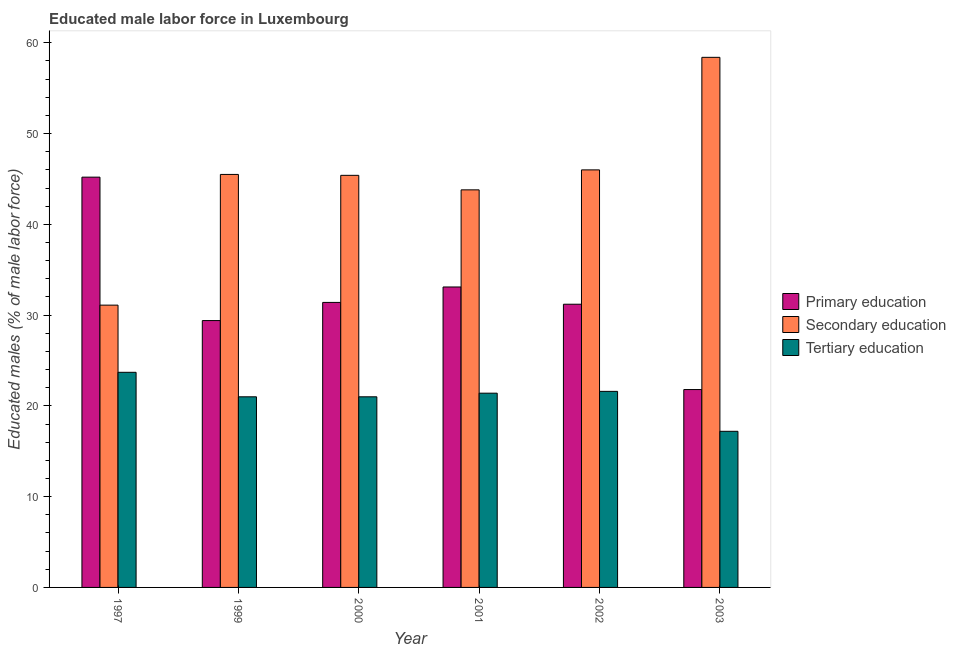How many groups of bars are there?
Offer a very short reply. 6. How many bars are there on the 4th tick from the right?
Your answer should be very brief. 3. What is the label of the 1st group of bars from the left?
Your answer should be compact. 1997. What is the percentage of male labor force who received tertiary education in 2002?
Give a very brief answer. 21.6. Across all years, what is the maximum percentage of male labor force who received tertiary education?
Make the answer very short. 23.7. Across all years, what is the minimum percentage of male labor force who received primary education?
Your answer should be compact. 21.8. In which year was the percentage of male labor force who received primary education minimum?
Make the answer very short. 2003. What is the total percentage of male labor force who received secondary education in the graph?
Offer a terse response. 270.2. What is the difference between the percentage of male labor force who received primary education in 2000 and that in 2001?
Keep it short and to the point. -1.7. What is the difference between the percentage of male labor force who received primary education in 1999 and the percentage of male labor force who received secondary education in 2001?
Your response must be concise. -3.7. What is the average percentage of male labor force who received secondary education per year?
Offer a terse response. 45.03. What is the ratio of the percentage of male labor force who received tertiary education in 1997 to that in 2002?
Ensure brevity in your answer.  1.1. Is the percentage of male labor force who received secondary education in 2002 less than that in 2003?
Your answer should be very brief. Yes. Is the difference between the percentage of male labor force who received tertiary education in 1997 and 2001 greater than the difference between the percentage of male labor force who received primary education in 1997 and 2001?
Give a very brief answer. No. What is the difference between the highest and the second highest percentage of male labor force who received secondary education?
Offer a very short reply. 12.4. What is the difference between the highest and the lowest percentage of male labor force who received tertiary education?
Your answer should be compact. 6.5. What does the 3rd bar from the left in 2001 represents?
Your answer should be compact. Tertiary education. Is it the case that in every year, the sum of the percentage of male labor force who received primary education and percentage of male labor force who received secondary education is greater than the percentage of male labor force who received tertiary education?
Keep it short and to the point. Yes. Are all the bars in the graph horizontal?
Provide a succinct answer. No. Does the graph contain any zero values?
Provide a short and direct response. No. Where does the legend appear in the graph?
Make the answer very short. Center right. How many legend labels are there?
Provide a succinct answer. 3. What is the title of the graph?
Your response must be concise. Educated male labor force in Luxembourg. Does "Transport" appear as one of the legend labels in the graph?
Make the answer very short. No. What is the label or title of the Y-axis?
Ensure brevity in your answer.  Educated males (% of male labor force). What is the Educated males (% of male labor force) of Primary education in 1997?
Your answer should be very brief. 45.2. What is the Educated males (% of male labor force) in Secondary education in 1997?
Offer a very short reply. 31.1. What is the Educated males (% of male labor force) of Tertiary education in 1997?
Provide a succinct answer. 23.7. What is the Educated males (% of male labor force) in Primary education in 1999?
Give a very brief answer. 29.4. What is the Educated males (% of male labor force) of Secondary education in 1999?
Keep it short and to the point. 45.5. What is the Educated males (% of male labor force) in Primary education in 2000?
Your answer should be very brief. 31.4. What is the Educated males (% of male labor force) of Secondary education in 2000?
Offer a very short reply. 45.4. What is the Educated males (% of male labor force) of Tertiary education in 2000?
Give a very brief answer. 21. What is the Educated males (% of male labor force) in Primary education in 2001?
Your answer should be compact. 33.1. What is the Educated males (% of male labor force) in Secondary education in 2001?
Your answer should be compact. 43.8. What is the Educated males (% of male labor force) in Tertiary education in 2001?
Offer a terse response. 21.4. What is the Educated males (% of male labor force) of Primary education in 2002?
Your answer should be very brief. 31.2. What is the Educated males (% of male labor force) of Secondary education in 2002?
Your response must be concise. 46. What is the Educated males (% of male labor force) in Tertiary education in 2002?
Make the answer very short. 21.6. What is the Educated males (% of male labor force) of Primary education in 2003?
Your answer should be compact. 21.8. What is the Educated males (% of male labor force) in Secondary education in 2003?
Give a very brief answer. 58.4. What is the Educated males (% of male labor force) in Tertiary education in 2003?
Your answer should be compact. 17.2. Across all years, what is the maximum Educated males (% of male labor force) of Primary education?
Keep it short and to the point. 45.2. Across all years, what is the maximum Educated males (% of male labor force) in Secondary education?
Ensure brevity in your answer.  58.4. Across all years, what is the maximum Educated males (% of male labor force) of Tertiary education?
Keep it short and to the point. 23.7. Across all years, what is the minimum Educated males (% of male labor force) of Primary education?
Give a very brief answer. 21.8. Across all years, what is the minimum Educated males (% of male labor force) of Secondary education?
Provide a succinct answer. 31.1. Across all years, what is the minimum Educated males (% of male labor force) in Tertiary education?
Ensure brevity in your answer.  17.2. What is the total Educated males (% of male labor force) of Primary education in the graph?
Your answer should be compact. 192.1. What is the total Educated males (% of male labor force) in Secondary education in the graph?
Provide a succinct answer. 270.2. What is the total Educated males (% of male labor force) in Tertiary education in the graph?
Offer a terse response. 125.9. What is the difference between the Educated males (% of male labor force) of Secondary education in 1997 and that in 1999?
Provide a short and direct response. -14.4. What is the difference between the Educated males (% of male labor force) in Tertiary education in 1997 and that in 1999?
Provide a succinct answer. 2.7. What is the difference between the Educated males (% of male labor force) of Secondary education in 1997 and that in 2000?
Your answer should be compact. -14.3. What is the difference between the Educated males (% of male labor force) of Tertiary education in 1997 and that in 2000?
Provide a short and direct response. 2.7. What is the difference between the Educated males (% of male labor force) in Primary education in 1997 and that in 2001?
Provide a succinct answer. 12.1. What is the difference between the Educated males (% of male labor force) of Tertiary education in 1997 and that in 2001?
Your answer should be compact. 2.3. What is the difference between the Educated males (% of male labor force) of Secondary education in 1997 and that in 2002?
Provide a succinct answer. -14.9. What is the difference between the Educated males (% of male labor force) of Primary education in 1997 and that in 2003?
Your answer should be compact. 23.4. What is the difference between the Educated males (% of male labor force) in Secondary education in 1997 and that in 2003?
Make the answer very short. -27.3. What is the difference between the Educated males (% of male labor force) of Primary education in 1999 and that in 2000?
Give a very brief answer. -2. What is the difference between the Educated males (% of male labor force) of Tertiary education in 1999 and that in 2000?
Your response must be concise. 0. What is the difference between the Educated males (% of male labor force) of Primary education in 1999 and that in 2001?
Your response must be concise. -3.7. What is the difference between the Educated males (% of male labor force) of Tertiary education in 1999 and that in 2001?
Offer a terse response. -0.4. What is the difference between the Educated males (% of male labor force) in Secondary education in 1999 and that in 2002?
Your answer should be very brief. -0.5. What is the difference between the Educated males (% of male labor force) of Primary education in 1999 and that in 2003?
Your answer should be very brief. 7.6. What is the difference between the Educated males (% of male labor force) of Secondary education in 2000 and that in 2001?
Your response must be concise. 1.6. What is the difference between the Educated males (% of male labor force) in Secondary education in 2000 and that in 2002?
Provide a succinct answer. -0.6. What is the difference between the Educated males (% of male labor force) of Secondary education in 2000 and that in 2003?
Provide a succinct answer. -13. What is the difference between the Educated males (% of male labor force) in Tertiary education in 2001 and that in 2002?
Give a very brief answer. -0.2. What is the difference between the Educated males (% of male labor force) of Primary education in 2001 and that in 2003?
Offer a very short reply. 11.3. What is the difference between the Educated males (% of male labor force) of Secondary education in 2001 and that in 2003?
Give a very brief answer. -14.6. What is the difference between the Educated males (% of male labor force) in Tertiary education in 2002 and that in 2003?
Keep it short and to the point. 4.4. What is the difference between the Educated males (% of male labor force) in Primary education in 1997 and the Educated males (% of male labor force) in Tertiary education in 1999?
Keep it short and to the point. 24.2. What is the difference between the Educated males (% of male labor force) in Secondary education in 1997 and the Educated males (% of male labor force) in Tertiary education in 1999?
Keep it short and to the point. 10.1. What is the difference between the Educated males (% of male labor force) of Primary education in 1997 and the Educated males (% of male labor force) of Secondary education in 2000?
Make the answer very short. -0.2. What is the difference between the Educated males (% of male labor force) in Primary education in 1997 and the Educated males (% of male labor force) in Tertiary education in 2000?
Ensure brevity in your answer.  24.2. What is the difference between the Educated males (% of male labor force) in Primary education in 1997 and the Educated males (% of male labor force) in Secondary education in 2001?
Offer a very short reply. 1.4. What is the difference between the Educated males (% of male labor force) in Primary education in 1997 and the Educated males (% of male labor force) in Tertiary education in 2001?
Your answer should be very brief. 23.8. What is the difference between the Educated males (% of male labor force) of Secondary education in 1997 and the Educated males (% of male labor force) of Tertiary education in 2001?
Keep it short and to the point. 9.7. What is the difference between the Educated males (% of male labor force) of Primary education in 1997 and the Educated males (% of male labor force) of Tertiary education in 2002?
Provide a succinct answer. 23.6. What is the difference between the Educated males (% of male labor force) of Primary education in 1997 and the Educated males (% of male labor force) of Secondary education in 2003?
Make the answer very short. -13.2. What is the difference between the Educated males (% of male labor force) in Primary education in 1997 and the Educated males (% of male labor force) in Tertiary education in 2003?
Make the answer very short. 28. What is the difference between the Educated males (% of male labor force) in Secondary education in 1997 and the Educated males (% of male labor force) in Tertiary education in 2003?
Offer a terse response. 13.9. What is the difference between the Educated males (% of male labor force) in Primary education in 1999 and the Educated males (% of male labor force) in Secondary education in 2000?
Offer a very short reply. -16. What is the difference between the Educated males (% of male labor force) of Secondary education in 1999 and the Educated males (% of male labor force) of Tertiary education in 2000?
Make the answer very short. 24.5. What is the difference between the Educated males (% of male labor force) of Primary education in 1999 and the Educated males (% of male labor force) of Secondary education in 2001?
Offer a very short reply. -14.4. What is the difference between the Educated males (% of male labor force) of Primary education in 1999 and the Educated males (% of male labor force) of Tertiary education in 2001?
Provide a succinct answer. 8. What is the difference between the Educated males (% of male labor force) of Secondary education in 1999 and the Educated males (% of male labor force) of Tertiary education in 2001?
Offer a very short reply. 24.1. What is the difference between the Educated males (% of male labor force) in Primary education in 1999 and the Educated males (% of male labor force) in Secondary education in 2002?
Give a very brief answer. -16.6. What is the difference between the Educated males (% of male labor force) in Primary education in 1999 and the Educated males (% of male labor force) in Tertiary education in 2002?
Keep it short and to the point. 7.8. What is the difference between the Educated males (% of male labor force) of Secondary education in 1999 and the Educated males (% of male labor force) of Tertiary education in 2002?
Your answer should be compact. 23.9. What is the difference between the Educated males (% of male labor force) of Primary education in 1999 and the Educated males (% of male labor force) of Tertiary education in 2003?
Your answer should be compact. 12.2. What is the difference between the Educated males (% of male labor force) of Secondary education in 1999 and the Educated males (% of male labor force) of Tertiary education in 2003?
Offer a terse response. 28.3. What is the difference between the Educated males (% of male labor force) of Primary education in 2000 and the Educated males (% of male labor force) of Secondary education in 2001?
Give a very brief answer. -12.4. What is the difference between the Educated males (% of male labor force) of Primary education in 2000 and the Educated males (% of male labor force) of Tertiary education in 2001?
Your answer should be compact. 10. What is the difference between the Educated males (% of male labor force) of Primary education in 2000 and the Educated males (% of male labor force) of Secondary education in 2002?
Offer a very short reply. -14.6. What is the difference between the Educated males (% of male labor force) of Secondary education in 2000 and the Educated males (% of male labor force) of Tertiary education in 2002?
Offer a terse response. 23.8. What is the difference between the Educated males (% of male labor force) of Primary education in 2000 and the Educated males (% of male labor force) of Secondary education in 2003?
Your response must be concise. -27. What is the difference between the Educated males (% of male labor force) of Secondary education in 2000 and the Educated males (% of male labor force) of Tertiary education in 2003?
Provide a short and direct response. 28.2. What is the difference between the Educated males (% of male labor force) in Primary education in 2001 and the Educated males (% of male labor force) in Secondary education in 2003?
Make the answer very short. -25.3. What is the difference between the Educated males (% of male labor force) of Secondary education in 2001 and the Educated males (% of male labor force) of Tertiary education in 2003?
Your answer should be compact. 26.6. What is the difference between the Educated males (% of male labor force) of Primary education in 2002 and the Educated males (% of male labor force) of Secondary education in 2003?
Your answer should be very brief. -27.2. What is the difference between the Educated males (% of male labor force) of Primary education in 2002 and the Educated males (% of male labor force) of Tertiary education in 2003?
Provide a succinct answer. 14. What is the difference between the Educated males (% of male labor force) of Secondary education in 2002 and the Educated males (% of male labor force) of Tertiary education in 2003?
Offer a terse response. 28.8. What is the average Educated males (% of male labor force) of Primary education per year?
Offer a very short reply. 32.02. What is the average Educated males (% of male labor force) of Secondary education per year?
Offer a very short reply. 45.03. What is the average Educated males (% of male labor force) in Tertiary education per year?
Make the answer very short. 20.98. In the year 1997, what is the difference between the Educated males (% of male labor force) in Secondary education and Educated males (% of male labor force) in Tertiary education?
Provide a short and direct response. 7.4. In the year 1999, what is the difference between the Educated males (% of male labor force) of Primary education and Educated males (% of male labor force) of Secondary education?
Keep it short and to the point. -16.1. In the year 1999, what is the difference between the Educated males (% of male labor force) in Primary education and Educated males (% of male labor force) in Tertiary education?
Give a very brief answer. 8.4. In the year 2000, what is the difference between the Educated males (% of male labor force) of Primary education and Educated males (% of male labor force) of Tertiary education?
Provide a succinct answer. 10.4. In the year 2000, what is the difference between the Educated males (% of male labor force) in Secondary education and Educated males (% of male labor force) in Tertiary education?
Provide a succinct answer. 24.4. In the year 2001, what is the difference between the Educated males (% of male labor force) in Primary education and Educated males (% of male labor force) in Tertiary education?
Your answer should be very brief. 11.7. In the year 2001, what is the difference between the Educated males (% of male labor force) of Secondary education and Educated males (% of male labor force) of Tertiary education?
Your response must be concise. 22.4. In the year 2002, what is the difference between the Educated males (% of male labor force) of Primary education and Educated males (% of male labor force) of Secondary education?
Your answer should be very brief. -14.8. In the year 2002, what is the difference between the Educated males (% of male labor force) in Secondary education and Educated males (% of male labor force) in Tertiary education?
Your answer should be very brief. 24.4. In the year 2003, what is the difference between the Educated males (% of male labor force) in Primary education and Educated males (% of male labor force) in Secondary education?
Provide a short and direct response. -36.6. In the year 2003, what is the difference between the Educated males (% of male labor force) of Primary education and Educated males (% of male labor force) of Tertiary education?
Provide a succinct answer. 4.6. In the year 2003, what is the difference between the Educated males (% of male labor force) in Secondary education and Educated males (% of male labor force) in Tertiary education?
Provide a short and direct response. 41.2. What is the ratio of the Educated males (% of male labor force) of Primary education in 1997 to that in 1999?
Keep it short and to the point. 1.54. What is the ratio of the Educated males (% of male labor force) in Secondary education in 1997 to that in 1999?
Ensure brevity in your answer.  0.68. What is the ratio of the Educated males (% of male labor force) of Tertiary education in 1997 to that in 1999?
Provide a short and direct response. 1.13. What is the ratio of the Educated males (% of male labor force) of Primary education in 1997 to that in 2000?
Provide a succinct answer. 1.44. What is the ratio of the Educated males (% of male labor force) in Secondary education in 1997 to that in 2000?
Your response must be concise. 0.69. What is the ratio of the Educated males (% of male labor force) in Tertiary education in 1997 to that in 2000?
Offer a very short reply. 1.13. What is the ratio of the Educated males (% of male labor force) in Primary education in 1997 to that in 2001?
Keep it short and to the point. 1.37. What is the ratio of the Educated males (% of male labor force) in Secondary education in 1997 to that in 2001?
Your answer should be compact. 0.71. What is the ratio of the Educated males (% of male labor force) in Tertiary education in 1997 to that in 2001?
Your answer should be very brief. 1.11. What is the ratio of the Educated males (% of male labor force) in Primary education in 1997 to that in 2002?
Offer a terse response. 1.45. What is the ratio of the Educated males (% of male labor force) in Secondary education in 1997 to that in 2002?
Your response must be concise. 0.68. What is the ratio of the Educated males (% of male labor force) in Tertiary education in 1997 to that in 2002?
Give a very brief answer. 1.1. What is the ratio of the Educated males (% of male labor force) of Primary education in 1997 to that in 2003?
Offer a terse response. 2.07. What is the ratio of the Educated males (% of male labor force) in Secondary education in 1997 to that in 2003?
Offer a very short reply. 0.53. What is the ratio of the Educated males (% of male labor force) in Tertiary education in 1997 to that in 2003?
Offer a very short reply. 1.38. What is the ratio of the Educated males (% of male labor force) in Primary education in 1999 to that in 2000?
Provide a succinct answer. 0.94. What is the ratio of the Educated males (% of male labor force) in Secondary education in 1999 to that in 2000?
Provide a short and direct response. 1. What is the ratio of the Educated males (% of male labor force) in Tertiary education in 1999 to that in 2000?
Your answer should be very brief. 1. What is the ratio of the Educated males (% of male labor force) of Primary education in 1999 to that in 2001?
Offer a very short reply. 0.89. What is the ratio of the Educated males (% of male labor force) of Secondary education in 1999 to that in 2001?
Give a very brief answer. 1.04. What is the ratio of the Educated males (% of male labor force) of Tertiary education in 1999 to that in 2001?
Offer a very short reply. 0.98. What is the ratio of the Educated males (% of male labor force) in Primary education in 1999 to that in 2002?
Provide a short and direct response. 0.94. What is the ratio of the Educated males (% of male labor force) of Secondary education in 1999 to that in 2002?
Ensure brevity in your answer.  0.99. What is the ratio of the Educated males (% of male labor force) of Tertiary education in 1999 to that in 2002?
Offer a terse response. 0.97. What is the ratio of the Educated males (% of male labor force) in Primary education in 1999 to that in 2003?
Provide a short and direct response. 1.35. What is the ratio of the Educated males (% of male labor force) in Secondary education in 1999 to that in 2003?
Keep it short and to the point. 0.78. What is the ratio of the Educated males (% of male labor force) of Tertiary education in 1999 to that in 2003?
Keep it short and to the point. 1.22. What is the ratio of the Educated males (% of male labor force) in Primary education in 2000 to that in 2001?
Ensure brevity in your answer.  0.95. What is the ratio of the Educated males (% of male labor force) of Secondary education in 2000 to that in 2001?
Give a very brief answer. 1.04. What is the ratio of the Educated males (% of male labor force) in Tertiary education in 2000 to that in 2001?
Offer a very short reply. 0.98. What is the ratio of the Educated males (% of male labor force) in Primary education in 2000 to that in 2002?
Provide a succinct answer. 1.01. What is the ratio of the Educated males (% of male labor force) of Secondary education in 2000 to that in 2002?
Offer a very short reply. 0.99. What is the ratio of the Educated males (% of male labor force) of Tertiary education in 2000 to that in 2002?
Make the answer very short. 0.97. What is the ratio of the Educated males (% of male labor force) in Primary education in 2000 to that in 2003?
Give a very brief answer. 1.44. What is the ratio of the Educated males (% of male labor force) of Secondary education in 2000 to that in 2003?
Give a very brief answer. 0.78. What is the ratio of the Educated males (% of male labor force) of Tertiary education in 2000 to that in 2003?
Make the answer very short. 1.22. What is the ratio of the Educated males (% of male labor force) in Primary education in 2001 to that in 2002?
Make the answer very short. 1.06. What is the ratio of the Educated males (% of male labor force) of Secondary education in 2001 to that in 2002?
Offer a terse response. 0.95. What is the ratio of the Educated males (% of male labor force) of Primary education in 2001 to that in 2003?
Offer a very short reply. 1.52. What is the ratio of the Educated males (% of male labor force) in Tertiary education in 2001 to that in 2003?
Offer a very short reply. 1.24. What is the ratio of the Educated males (% of male labor force) in Primary education in 2002 to that in 2003?
Keep it short and to the point. 1.43. What is the ratio of the Educated males (% of male labor force) in Secondary education in 2002 to that in 2003?
Your response must be concise. 0.79. What is the ratio of the Educated males (% of male labor force) in Tertiary education in 2002 to that in 2003?
Ensure brevity in your answer.  1.26. What is the difference between the highest and the second highest Educated males (% of male labor force) of Primary education?
Your answer should be compact. 12.1. What is the difference between the highest and the second highest Educated males (% of male labor force) in Secondary education?
Ensure brevity in your answer.  12.4. What is the difference between the highest and the second highest Educated males (% of male labor force) in Tertiary education?
Provide a succinct answer. 2.1. What is the difference between the highest and the lowest Educated males (% of male labor force) in Primary education?
Keep it short and to the point. 23.4. What is the difference between the highest and the lowest Educated males (% of male labor force) of Secondary education?
Ensure brevity in your answer.  27.3. What is the difference between the highest and the lowest Educated males (% of male labor force) of Tertiary education?
Offer a very short reply. 6.5. 